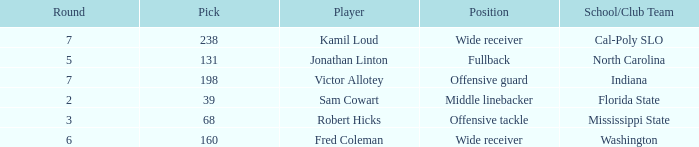Which School/Club Team has a Pick of 198? Indiana. 